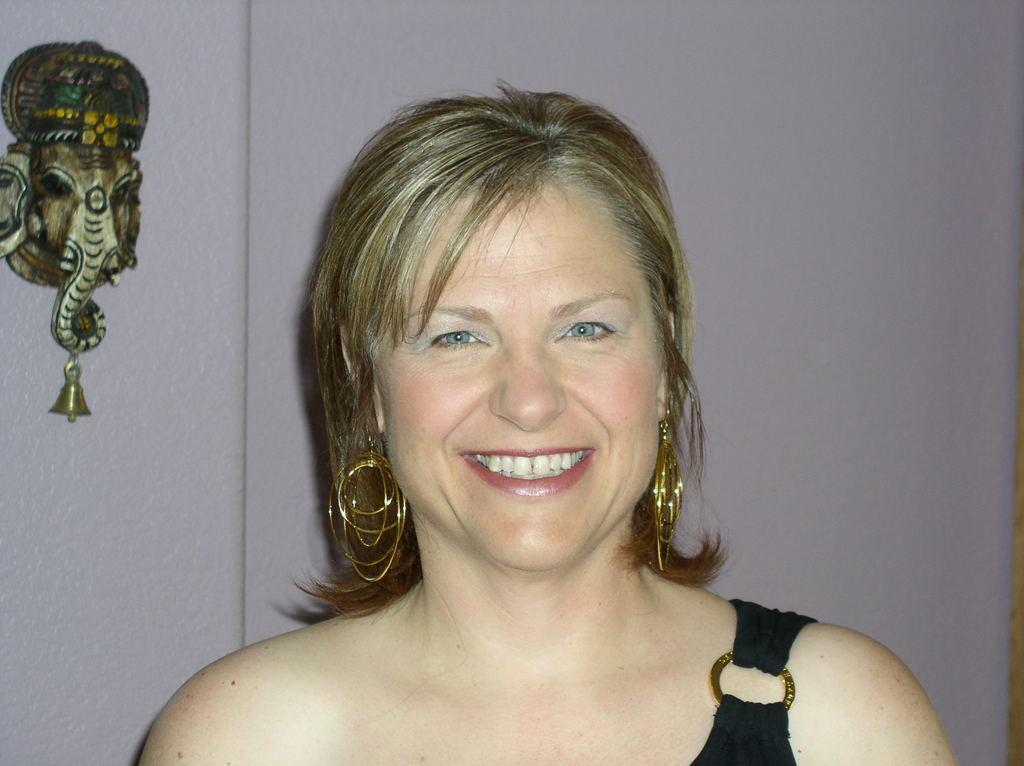Describe this image in one or two sentences. In this image we can see a lady smiling. In the background there is a wall and we can see a decor placed on the wall. 